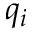<formula> <loc_0><loc_0><loc_500><loc_500>q _ { i }</formula> 